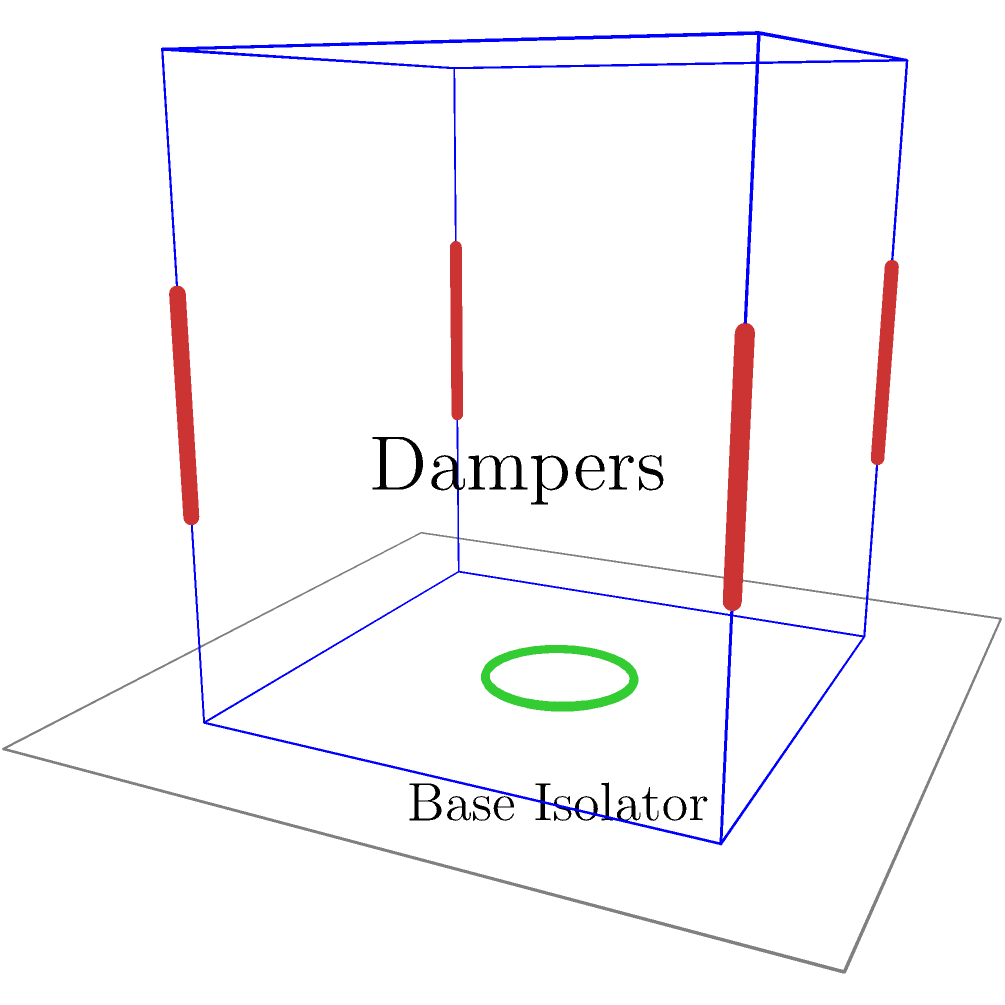In the 3D structural model shown, which combination of earthquake-resistant techniques is employed, and how does this configuration enhance the building's seismic performance compared to traditional designs? 1. Identification of techniques:
   - The model shows a building frame with two primary earthquake-resistant techniques:
     a) Dampers (red vertical elements)
     b) Base isolator (green circular element at the base)

2. Dampers:
   - Located at the corners of the building
   - Function: Dissipate seismic energy through deformation or friction
   - Reduce building motion and structural stress during an earthquake

3. Base isolator:
   - Located at the foundation level
   - Function: Decouples the building from ground motion
   - Allows the ground to move relative to the building, reducing forces transmitted to the structure

4. Combined effect:
   - Base isolation reduces the overall seismic force entering the building
   - Dampers further dissipate any remaining energy that does enter the structure

5. Comparison to traditional designs:
   - Traditional designs rely on the building's structural elements to resist seismic forces directly
   - This modern approach allows for more flexible, lighter structures that can better withstand earthquakes

6. Benefits of this configuration:
   - Increased safety: Reduced likelihood of structural failure
   - Improved performance: Less damage and downtime after an earthquake
   - Cost-effective in the long term: Reduced repair and replacement costs

7. Relevance to contemporary issues:
   - Addresses increasing urbanization in seismic zones
   - Aligns with sustainable design principles by reducing potential for earthquake damage
   - Utilizes advanced materials and computational modeling for optimized performance
Answer: Dampers and base isolation, providing enhanced energy dissipation and ground motion decoupling for superior seismic performance. 